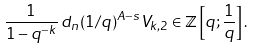<formula> <loc_0><loc_0><loc_500><loc_500>\frac { 1 } { 1 - q ^ { - k } } \, d _ { n } ( 1 / q ) ^ { A - s } V _ { k , 2 } \in \mathbb { Z } \left [ q ; \frac { 1 } { q } \right ] .</formula> 